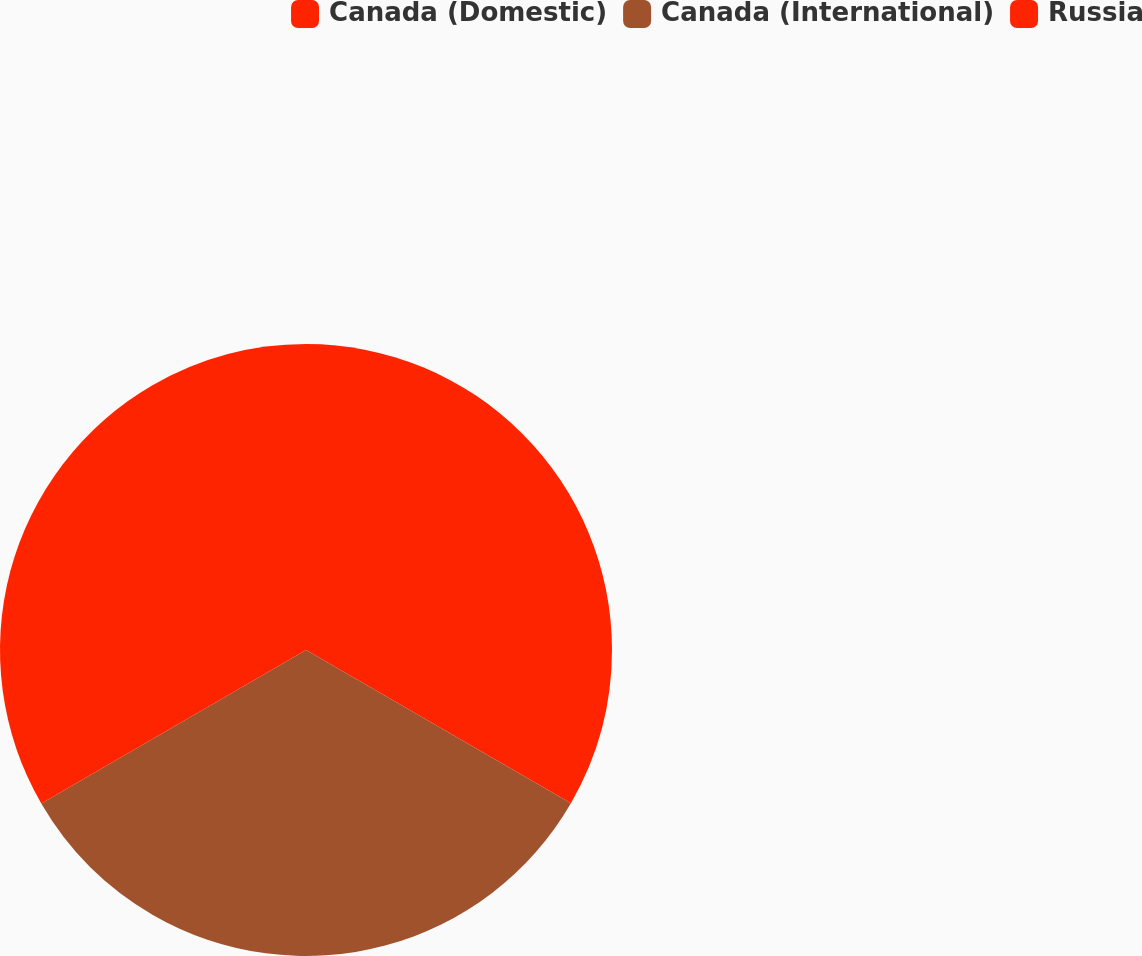Convert chart. <chart><loc_0><loc_0><loc_500><loc_500><pie_chart><fcel>Canada (Domestic)<fcel>Canada (International)<fcel>Russia<nl><fcel>33.34%<fcel>33.29%<fcel>33.36%<nl></chart> 